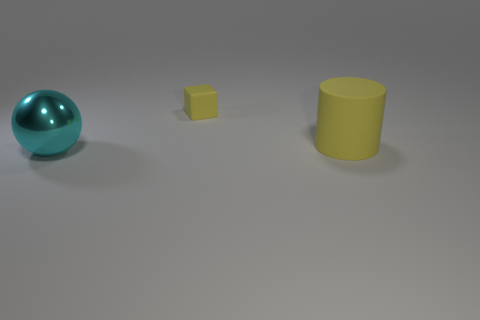Are there any other things that have the same color as the matte cube?
Ensure brevity in your answer.  Yes. Do the big object to the right of the cyan ball and the small rubber thing have the same shape?
Offer a very short reply. No. There is a cube that is the same color as the large matte thing; what size is it?
Provide a short and direct response. Small. Is there a rubber object of the same color as the large rubber cylinder?
Your answer should be very brief. Yes. The large thing that is behind the shiny ball that is in front of the thing that is to the right of the small yellow thing is what shape?
Give a very brief answer. Cylinder. There is a object that is to the left of the small thing; what is its material?
Your answer should be very brief. Metal. What size is the yellow rubber object in front of the yellow thing behind the object that is right of the yellow matte block?
Your answer should be compact. Large. Does the yellow matte cylinder have the same size as the object in front of the cylinder?
Provide a short and direct response. Yes. There is a large thing that is behind the cyan metallic object; what is its color?
Your response must be concise. Yellow. What shape is the other thing that is the same color as the big matte thing?
Make the answer very short. Cube. 